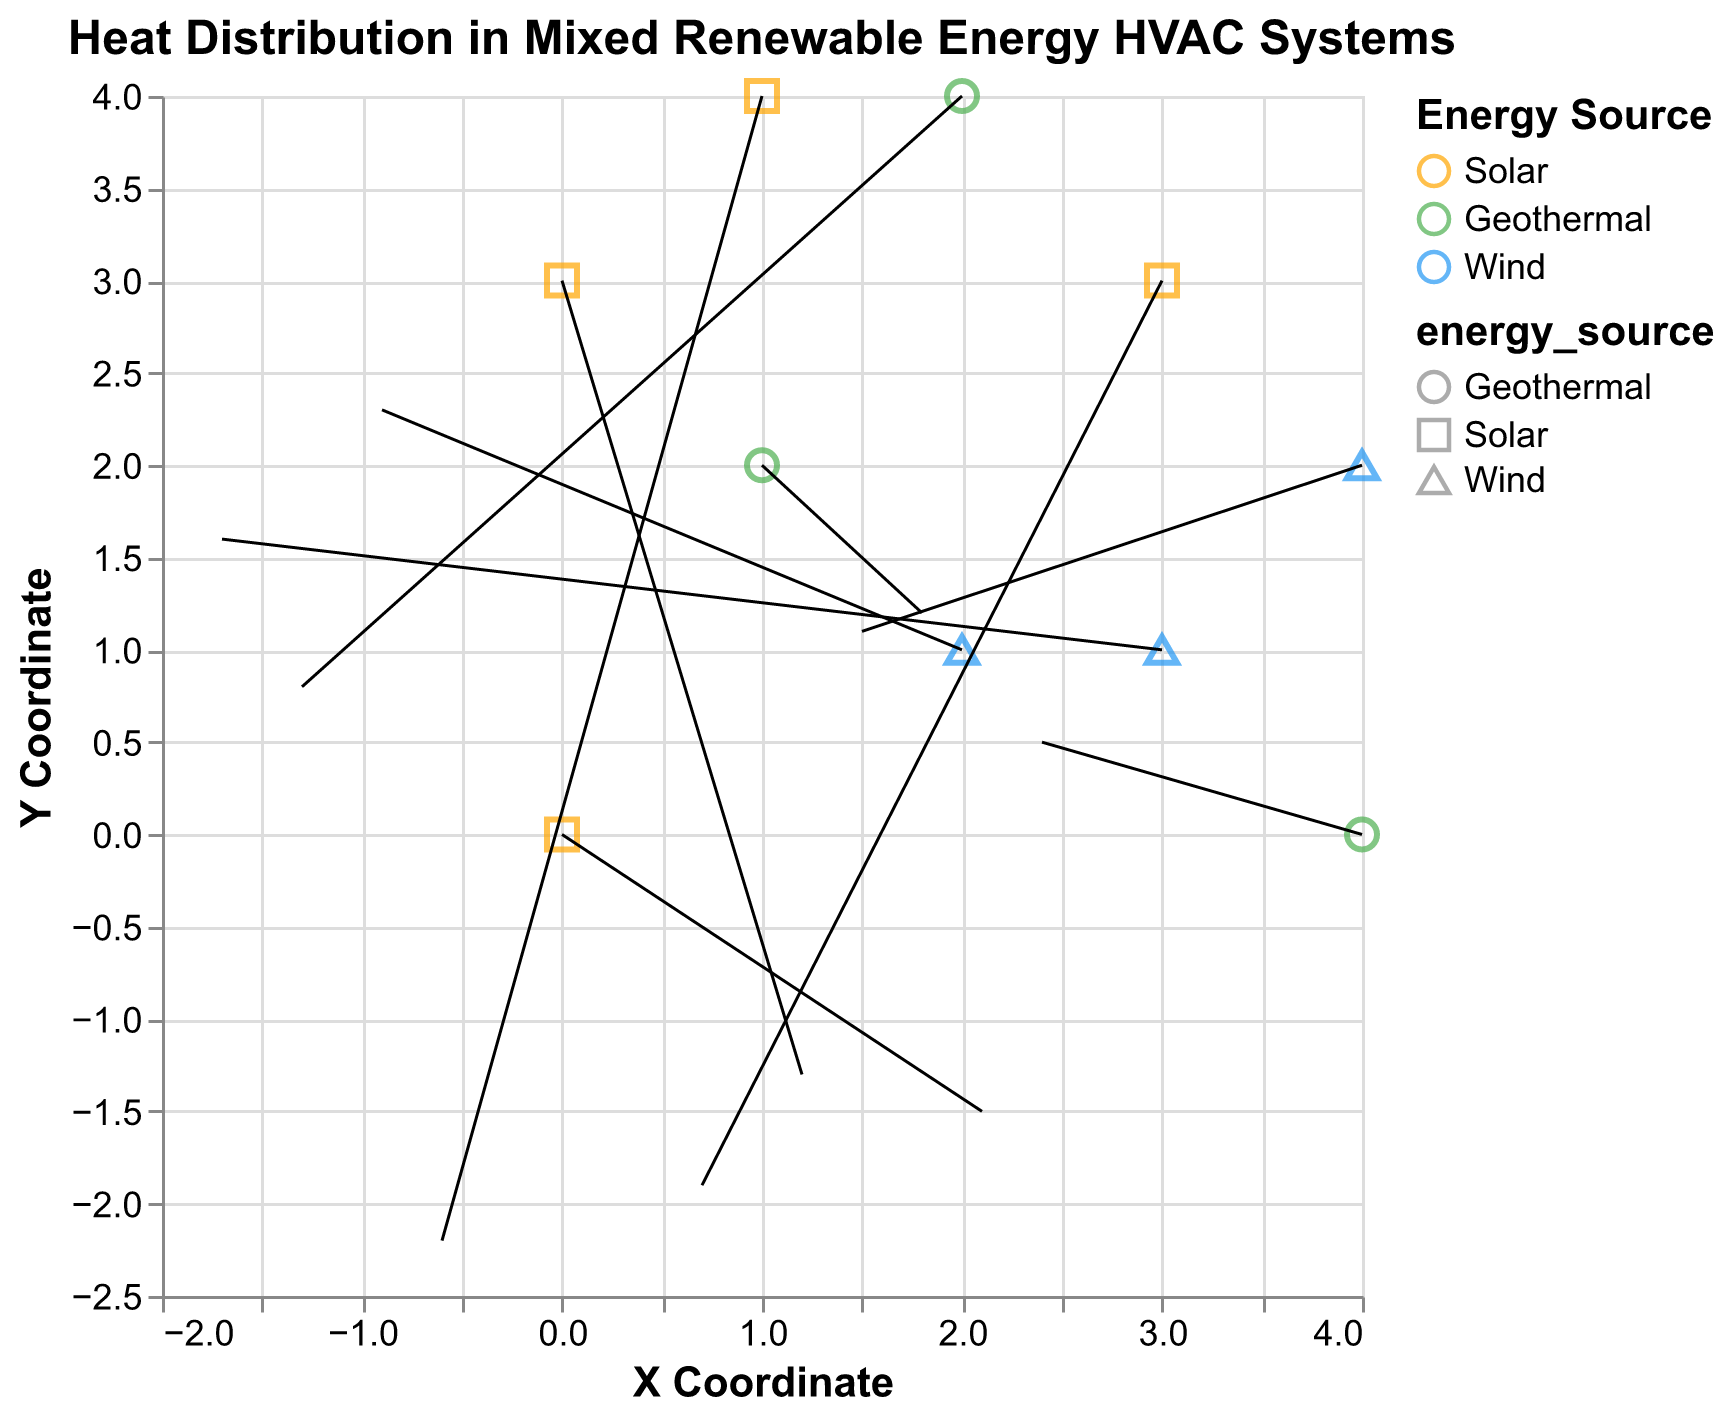What's the title of the figure? The title of the figure is displayed at the top, "Heat Distribution in Mixed Renewable Energy HVAC Systems".
Answer: Heat Distribution in Mixed Renewable Energy HVAC Systems How many different types of energy sources are shown in the figure? By examining the color legend on the figure, we can see three different energy sources: Solar, Geothermal, and Wind.
Answer: 3 Which color represents the "Wind" energy source in the figure? The legend indicates that the color representing "Wind" is blue.
Answer: Blue Which data point has the highest positive U component? By examining the U components in the figure, the data point at coordinates (4, 0) with a U value of 2.4 has the highest positive U component.
Answer: (4, 0) How many data points are marked with "Solar" energy source? Counting the data points color-coded and shaped according to the legend, we see that there are 4 data points for the "Solar" energy source.
Answer: 4 At which coordinates is the heat distributed most towards the right? The heat is distributed most towards the right where the U component is maximum. The point at (4,0) has a U component of 2.4, which is the highest value in this set.
Answer: (4,0) What is the average Y component (v) for the "Geothermal" energy source data points? The Y components (v) for the "Geothermal" energy source are 1.2, 0.8, and 0.5. We calculate the average as (1.2 + 0.8 + 0.5) / 3 = 2.5 / 3 = 0.83 (approx).
Answer: 0.83 What is the direction of heat distribution at the coordinates (1, 4)? The vector at coordinates (1, 4) has the components U = -0.6 and V = -2.2, indicating distribution downwards and slightly to the left.
Answer: Down-left How many data points show heat distribution with a negative U component? Identifying the points with a negative U component, the points at (2, 1), (2, 4), (3, 1), and (1, 4) have negative U values. Thus, there are 4 data points in total.
Answer: 4 Among the "Solar" energy source points, which one has the largest change in heat distribution magnitude? To determine the magnitude change for "Solar" points, we calculate sqrt(U^2 + V^2) for each:
(0, 0): sqrt(2.1^2 + (-1.5)^2) = 2.6 (approx)
(3, 3): sqrt(0.7^2 + (-1.9)^2) = 2.03 (approx)
(1, 4): sqrt((-0.6)^2 + (-2.2)^2) = 2.3 (approx)
(0, 3): sqrt(1.2^2 + (-1.3)^2) = 1.77 (approx)
The largest change in magnitude is at (0, 0).
Answer: (0, 0) 